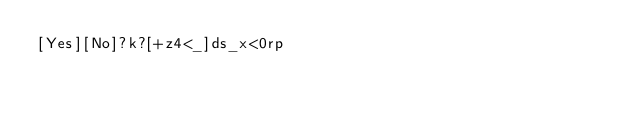Convert code to text. <code><loc_0><loc_0><loc_500><loc_500><_dc_>[Yes][No]?k?[+z4<_]ds_x<0rp</code> 